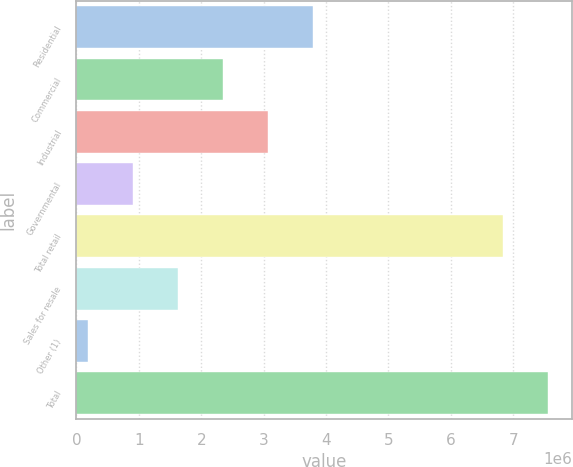<chart> <loc_0><loc_0><loc_500><loc_500><bar_chart><fcel>Residential<fcel>Commercial<fcel>Industrial<fcel>Governmental<fcel>Total retail<fcel>Sales for resale<fcel>Other (1)<fcel>Total<nl><fcel>3.79053e+06<fcel>2.34787e+06<fcel>3.0692e+06<fcel>905217<fcel>6.84164e+06<fcel>1.62655e+06<fcel>183888<fcel>7.56297e+06<nl></chart> 